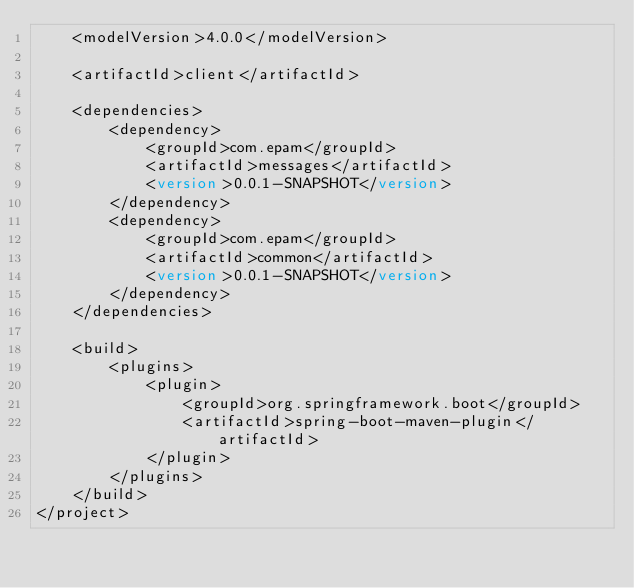Convert code to text. <code><loc_0><loc_0><loc_500><loc_500><_XML_>    <modelVersion>4.0.0</modelVersion>

    <artifactId>client</artifactId>

    <dependencies>
        <dependency>
            <groupId>com.epam</groupId>
            <artifactId>messages</artifactId>
            <version>0.0.1-SNAPSHOT</version>
        </dependency>
        <dependency>
            <groupId>com.epam</groupId>
            <artifactId>common</artifactId>
            <version>0.0.1-SNAPSHOT</version>
        </dependency>
    </dependencies>

    <build>
        <plugins>
            <plugin>
                <groupId>org.springframework.boot</groupId>
                <artifactId>spring-boot-maven-plugin</artifactId>
            </plugin>
        </plugins>
    </build>
</project></code> 